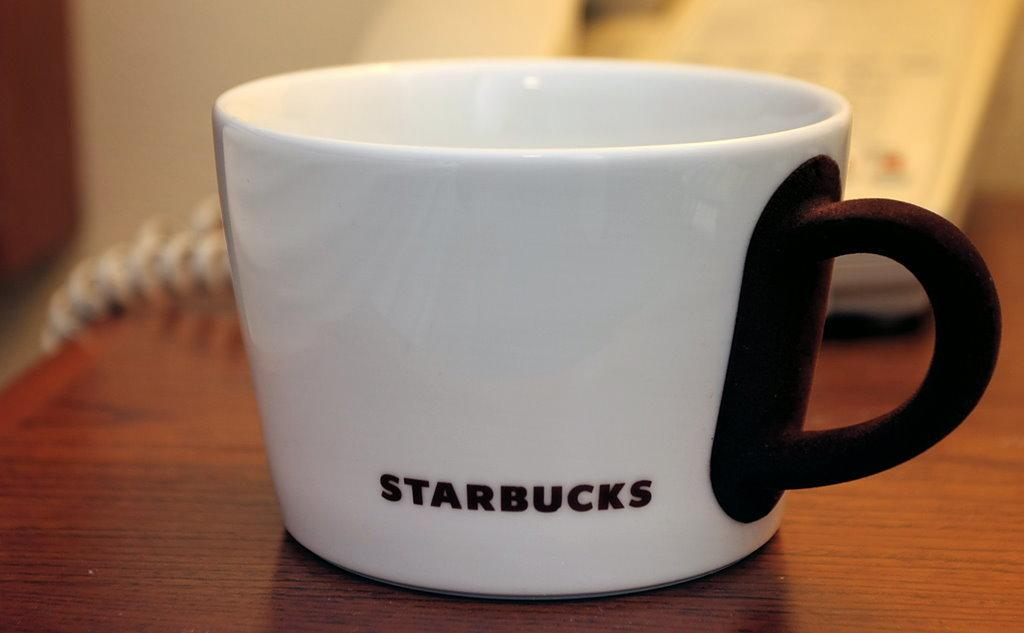Provide a one-sentence caption for the provided image. A white cup with a brown handle and Starbucks printed on it sits alone on a wooden table. 